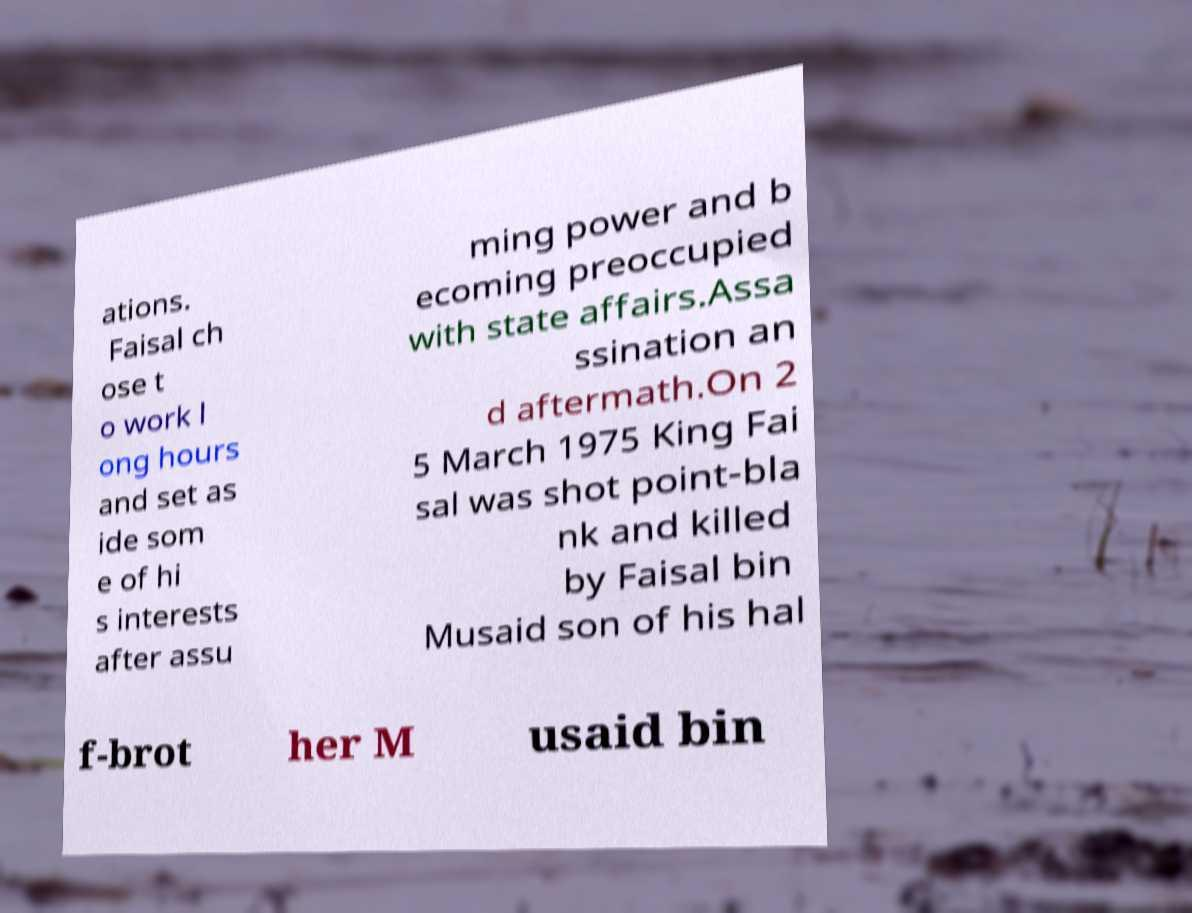Can you read and provide the text displayed in the image?This photo seems to have some interesting text. Can you extract and type it out for me? ations. Faisal ch ose t o work l ong hours and set as ide som e of hi s interests after assu ming power and b ecoming preoccupied with state affairs.Assa ssination an d aftermath.On 2 5 March 1975 King Fai sal was shot point-bla nk and killed by Faisal bin Musaid son of his hal f-brot her M usaid bin 